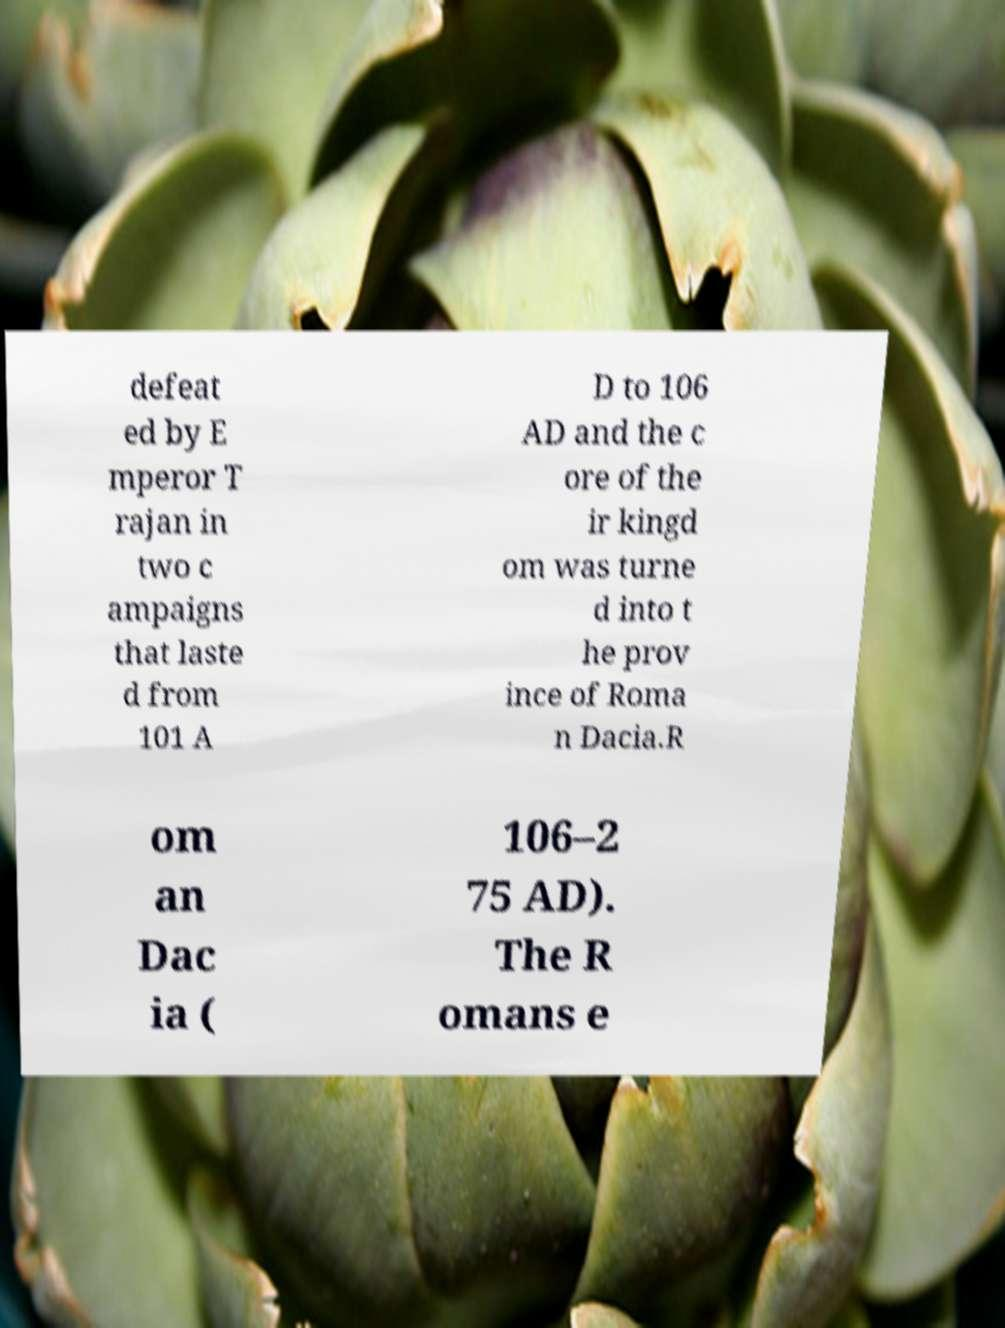Can you read and provide the text displayed in the image?This photo seems to have some interesting text. Can you extract and type it out for me? defeat ed by E mperor T rajan in two c ampaigns that laste d from 101 A D to 106 AD and the c ore of the ir kingd om was turne d into t he prov ince of Roma n Dacia.R om an Dac ia ( 106–2 75 AD). The R omans e 